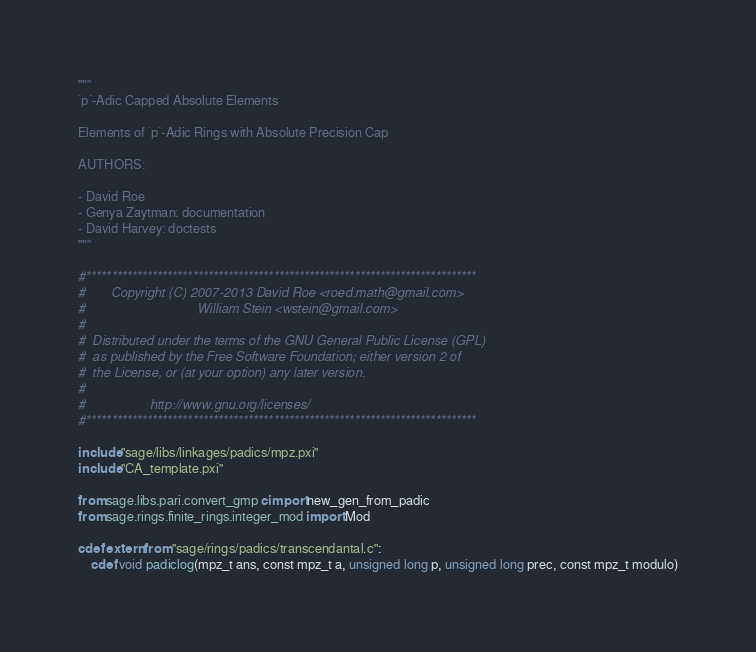<code> <loc_0><loc_0><loc_500><loc_500><_Cython_>"""
`p`-Adic Capped Absolute Elements

Elements of `p`-Adic Rings with Absolute Precision Cap

AUTHORS:

- David Roe
- Genya Zaytman: documentation
- David Harvey: doctests
"""

#*****************************************************************************
#       Copyright (C) 2007-2013 David Roe <roed.math@gmail.com>
#                               William Stein <wstein@gmail.com>
#
#  Distributed under the terms of the GNU General Public License (GPL)
#  as published by the Free Software Foundation; either version 2 of
#  the License, or (at your option) any later version.
#
#                  http://www.gnu.org/licenses/
#*****************************************************************************

include "sage/libs/linkages/padics/mpz.pxi"
include "CA_template.pxi"

from sage.libs.pari.convert_gmp cimport new_gen_from_padic
from sage.rings.finite_rings.integer_mod import Mod

cdef extern from "sage/rings/padics/transcendantal.c":
    cdef void padiclog(mpz_t ans, const mpz_t a, unsigned long p, unsigned long prec, const mpz_t modulo)</code> 